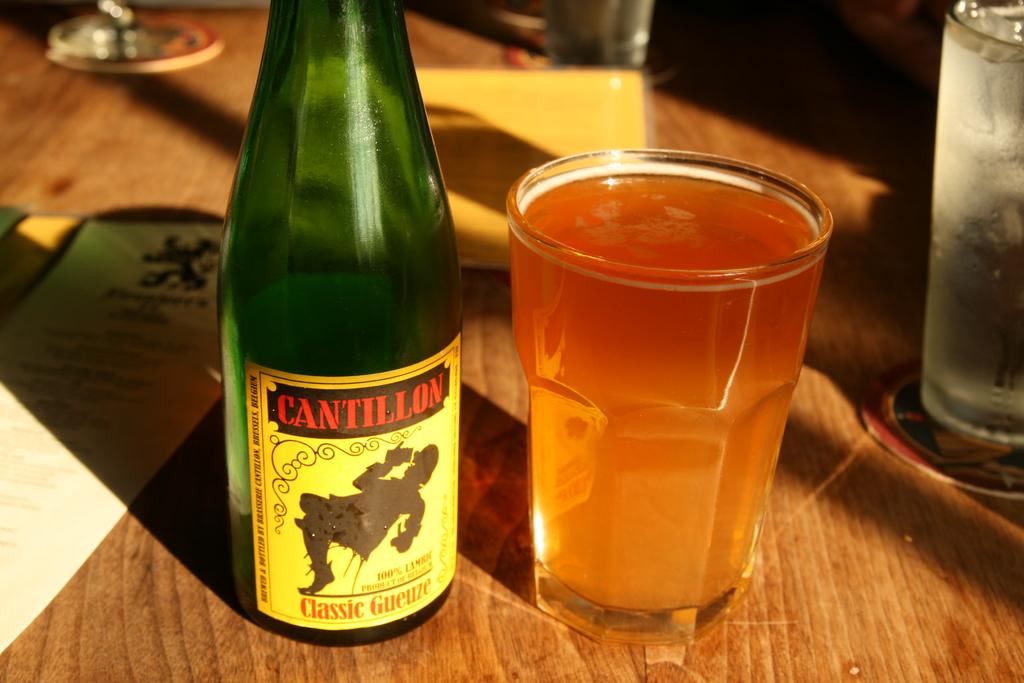What brand is the beverage?
Provide a succinct answer. Cantillon. Is it a classic?
Your answer should be compact. Yes. 